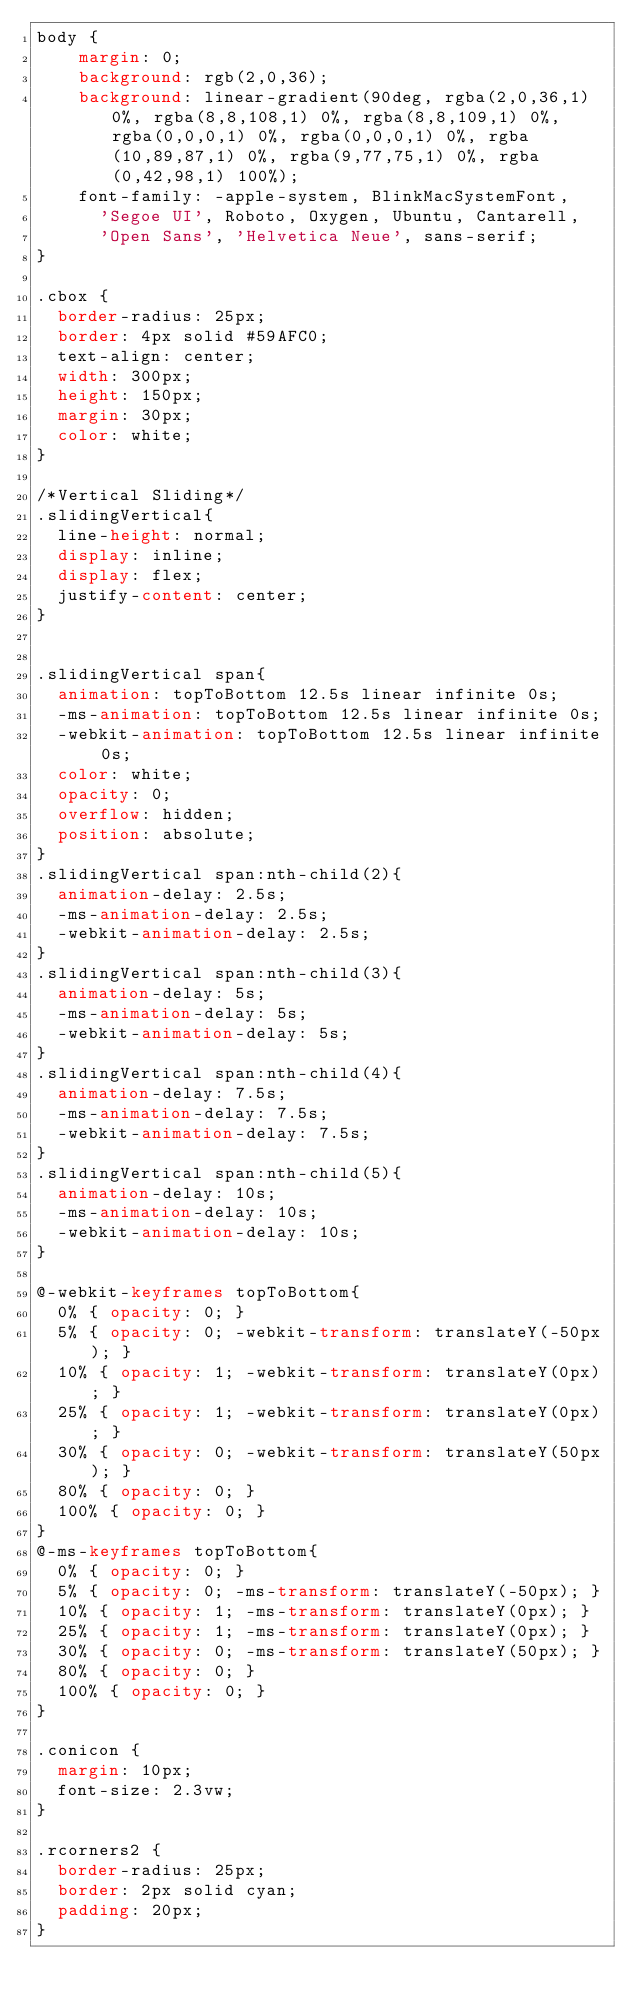<code> <loc_0><loc_0><loc_500><loc_500><_CSS_>body {
    margin: 0;
    background: rgb(2,0,36);
    background: linear-gradient(90deg, rgba(2,0,36,1) 0%, rgba(8,8,108,1) 0%, rgba(8,8,109,1) 0%, rgba(0,0,0,1) 0%, rgba(0,0,0,1) 0%, rgba(10,89,87,1) 0%, rgba(9,77,75,1) 0%, rgba(0,42,98,1) 100%);
    font-family: -apple-system, BlinkMacSystemFont,
      'Segoe UI', Roboto, Oxygen, Ubuntu, Cantarell,
      'Open Sans', 'Helvetica Neue', sans-serif;
}

.cbox {
  border-radius: 25px;
  border: 4px solid #59AFC0;
  text-align: center;
  width: 300px;
  height: 150px;
  margin: 30px;
  color: white;
}

/*Vertical Sliding*/
.slidingVertical{
  line-height: normal;
	display: inline;
  display: flex;
  justify-content: center;
}


.slidingVertical span{
  animation: topToBottom 12.5s linear infinite 0s;
  -ms-animation: topToBottom 12.5s linear infinite 0s;
  -webkit-animation: topToBottom 12.5s linear infinite 0s;
  color: white;
  opacity: 0;
  overflow: hidden;
  position: absolute;
}
.slidingVertical span:nth-child(2){
  animation-delay: 2.5s;
  -ms-animation-delay: 2.5s;
  -webkit-animation-delay: 2.5s;
}
.slidingVertical span:nth-child(3){
  animation-delay: 5s;
  -ms-animation-delay: 5s;
  -webkit-animation-delay: 5s;
}
.slidingVertical span:nth-child(4){
  animation-delay: 7.5s;
  -ms-animation-delay: 7.5s;
  -webkit-animation-delay: 7.5s;
}
.slidingVertical span:nth-child(5){
  animation-delay: 10s;
  -ms-animation-delay: 10s;
  -webkit-animation-delay: 10s;
}

@-webkit-keyframes topToBottom{
	0% { opacity: 0; }
	5% { opacity: 0; -webkit-transform: translateY(-50px); }
	10% { opacity: 1; -webkit-transform: translateY(0px); }
	25% { opacity: 1; -webkit-transform: translateY(0px); }
	30% { opacity: 0; -webkit-transform: translateY(50px); }
	80% { opacity: 0; }
	100% { opacity: 0; }
}
@-ms-keyframes topToBottom{
	0% { opacity: 0; }
	5% { opacity: 0; -ms-transform: translateY(-50px); }
	10% { opacity: 1; -ms-transform: translateY(0px); }
	25% { opacity: 1; -ms-transform: translateY(0px); }
	30% { opacity: 0; -ms-transform: translateY(50px); }
	80% { opacity: 0; }
	100% { opacity: 0; }
}

.conicon {
  margin: 10px;
  font-size: 2.3vw;
}

.rcorners2 {
  border-radius: 25px;
  border: 2px solid cyan;
  padding: 20px;
}
</code> 